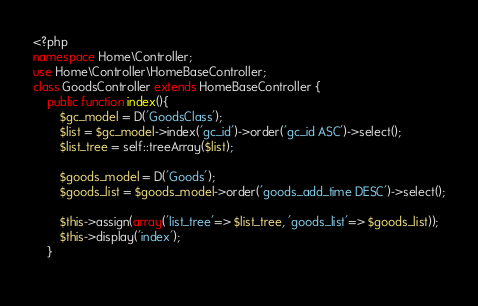<code> <loc_0><loc_0><loc_500><loc_500><_PHP_><?php
namespace Home\Controller;
use Home\Controller\HomeBaseController;
class GoodsController extends HomeBaseController {
    public function index(){
        $gc_model = D('GoodsClass');
        $list = $gc_model->index('gc_id')->order('gc_id ASC')->select();
        $list_tree = self::treeArray($list);
        
        $goods_model = D('Goods');
        $goods_list = $goods_model->order('goods_add_time DESC')->select();
        
        $this->assign(array('list_tree'=> $list_tree, 'goods_list'=> $goods_list));
        $this->display('index');
    }
    </code> 